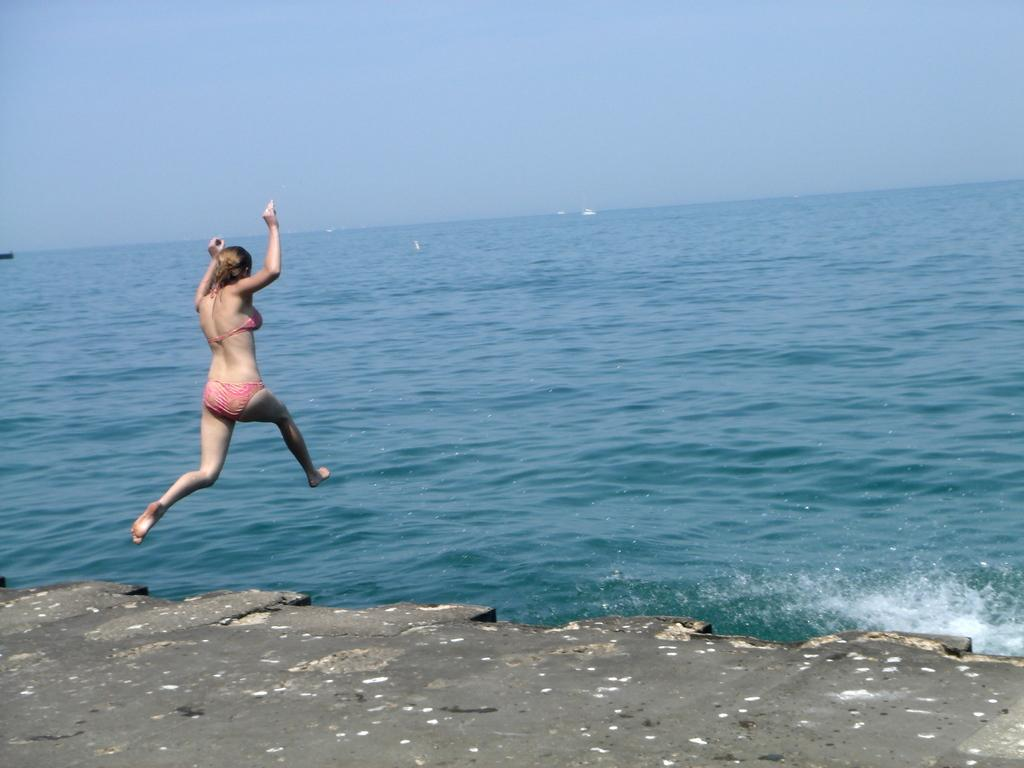What is the main subject of the image? The main subject of the image is a lady. What is the lady doing in the image? The lady is jumping into the water. What can be seen in the background of the image? There is sky visible in the background of the image. Can you see any cactus plants in the image? There is no cactus plant present in the image. What type of leather material is visible on the lady in the image? There is no leather material visible on the lady in the image. 